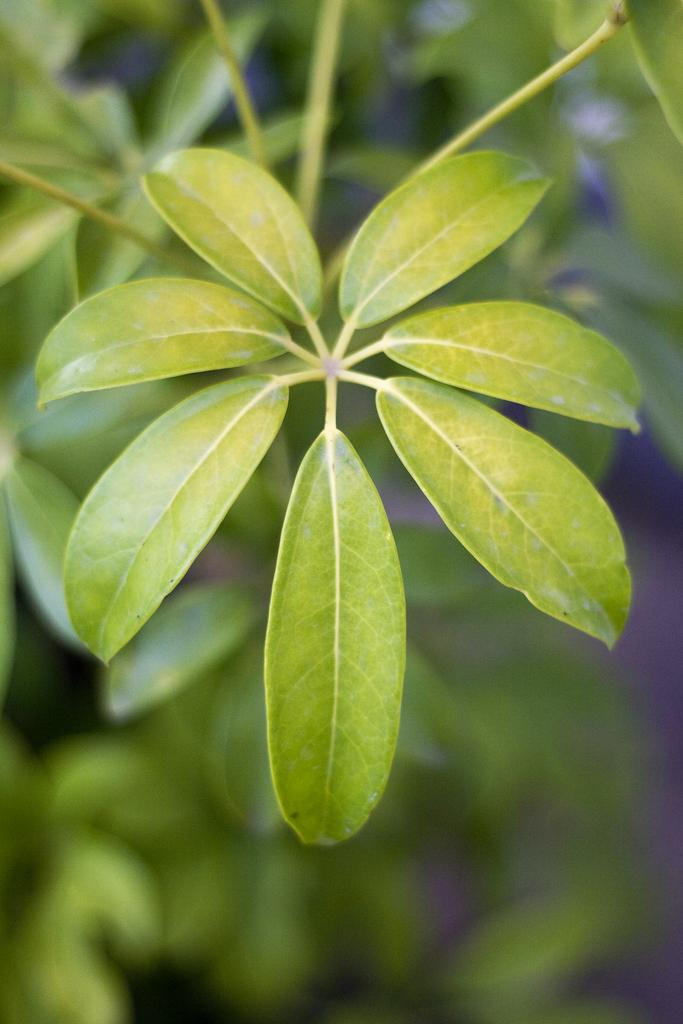How many leaves are visible on the plant in the foreground of the image? There are seven leaves on the plant in the foreground of the image. What can be seen on the right side of the image? There is a path on the right side of the image. What type of fog can be seen in the image? There is no fog present in the image. What activity is taking place on the path in the image? The image does not show any activity taking place on the path. 